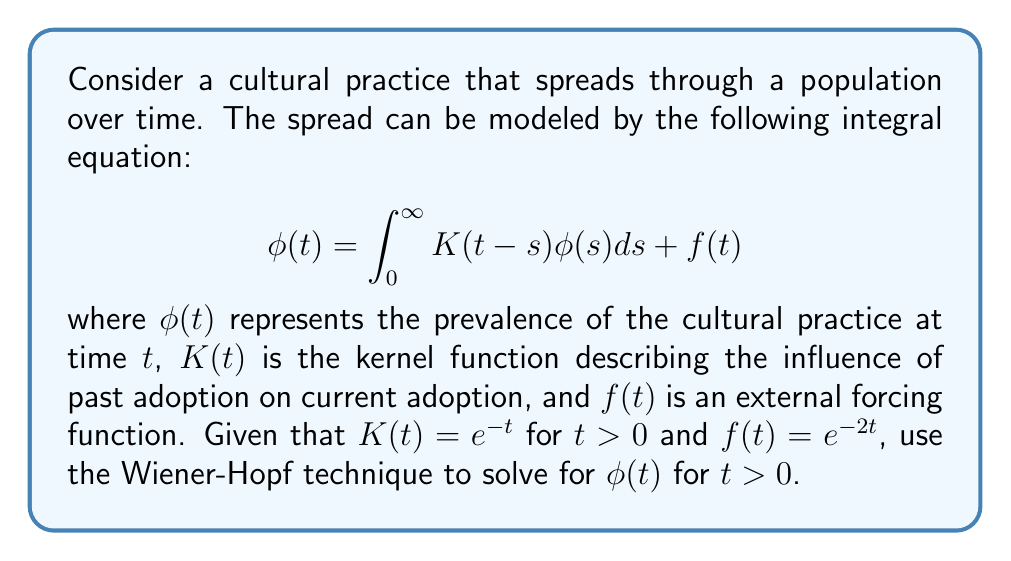Teach me how to tackle this problem. To solve this integral equation using the Wiener-Hopf technique, we'll follow these steps:

1) First, we extend the equation to the entire real line:

   $$\phi(t) = \int_{-\infty}^{\infty} K(t-s)\phi(s)ds + f(t)$$

   where $K(t) = e^{-t}H(t)$ and $H(t)$ is the Heaviside step function.

2) Take the Fourier transform of both sides:

   $$\Phi(\omega) = \hat{K}(\omega)\Phi(\omega) + F(\omega)$$

   where $\Phi(\omega)$, $\hat{K}(\omega)$, and $F(\omega)$ are the Fourier transforms of $\phi(t)$, $K(t)$, and $f(t)$ respectively.

3) Calculate $\hat{K}(\omega)$:

   $$\hat{K}(\omega) = \int_{-\infty}^{\infty} e^{-t}H(t)e^{-i\omega t}dt = \frac{1}{1+i\omega}$$

4) Calculate $F(\omega)$:

   $$F(\omega) = \int_{-\infty}^{\infty} e^{-2t}e^{-i\omega t}dt = \frac{1}{2+i\omega}$$

5) Substitute these into the transformed equation:

   $$\Phi(\omega) = \frac{1}{1+i\omega}\Phi(\omega) + \frac{1}{2+i\omega}$$

6) Rearrange to get:

   $$\Phi(\omega)\left(1 - \frac{1}{1+i\omega}\right) = \frac{1}{2+i\omega}$$

   $$\Phi(\omega)\frac{i\omega}{1+i\omega} = \frac{1}{2+i\omega}$$

7) Solve for $\Phi(\omega)$:

   $$\Phi(\omega) = \frac{1+i\omega}{i\omega(2+i\omega)} = \frac{1}{i\omega} - \frac{1}{2+i\omega}$$

8) Take the inverse Fourier transform:

   $$\phi(t) = H(t) - e^{-2t}$$

This is the solution for $t > 0$, as required by the question.
Answer: $\phi(t) = 1 - e^{-2t}$ for $t > 0$ 